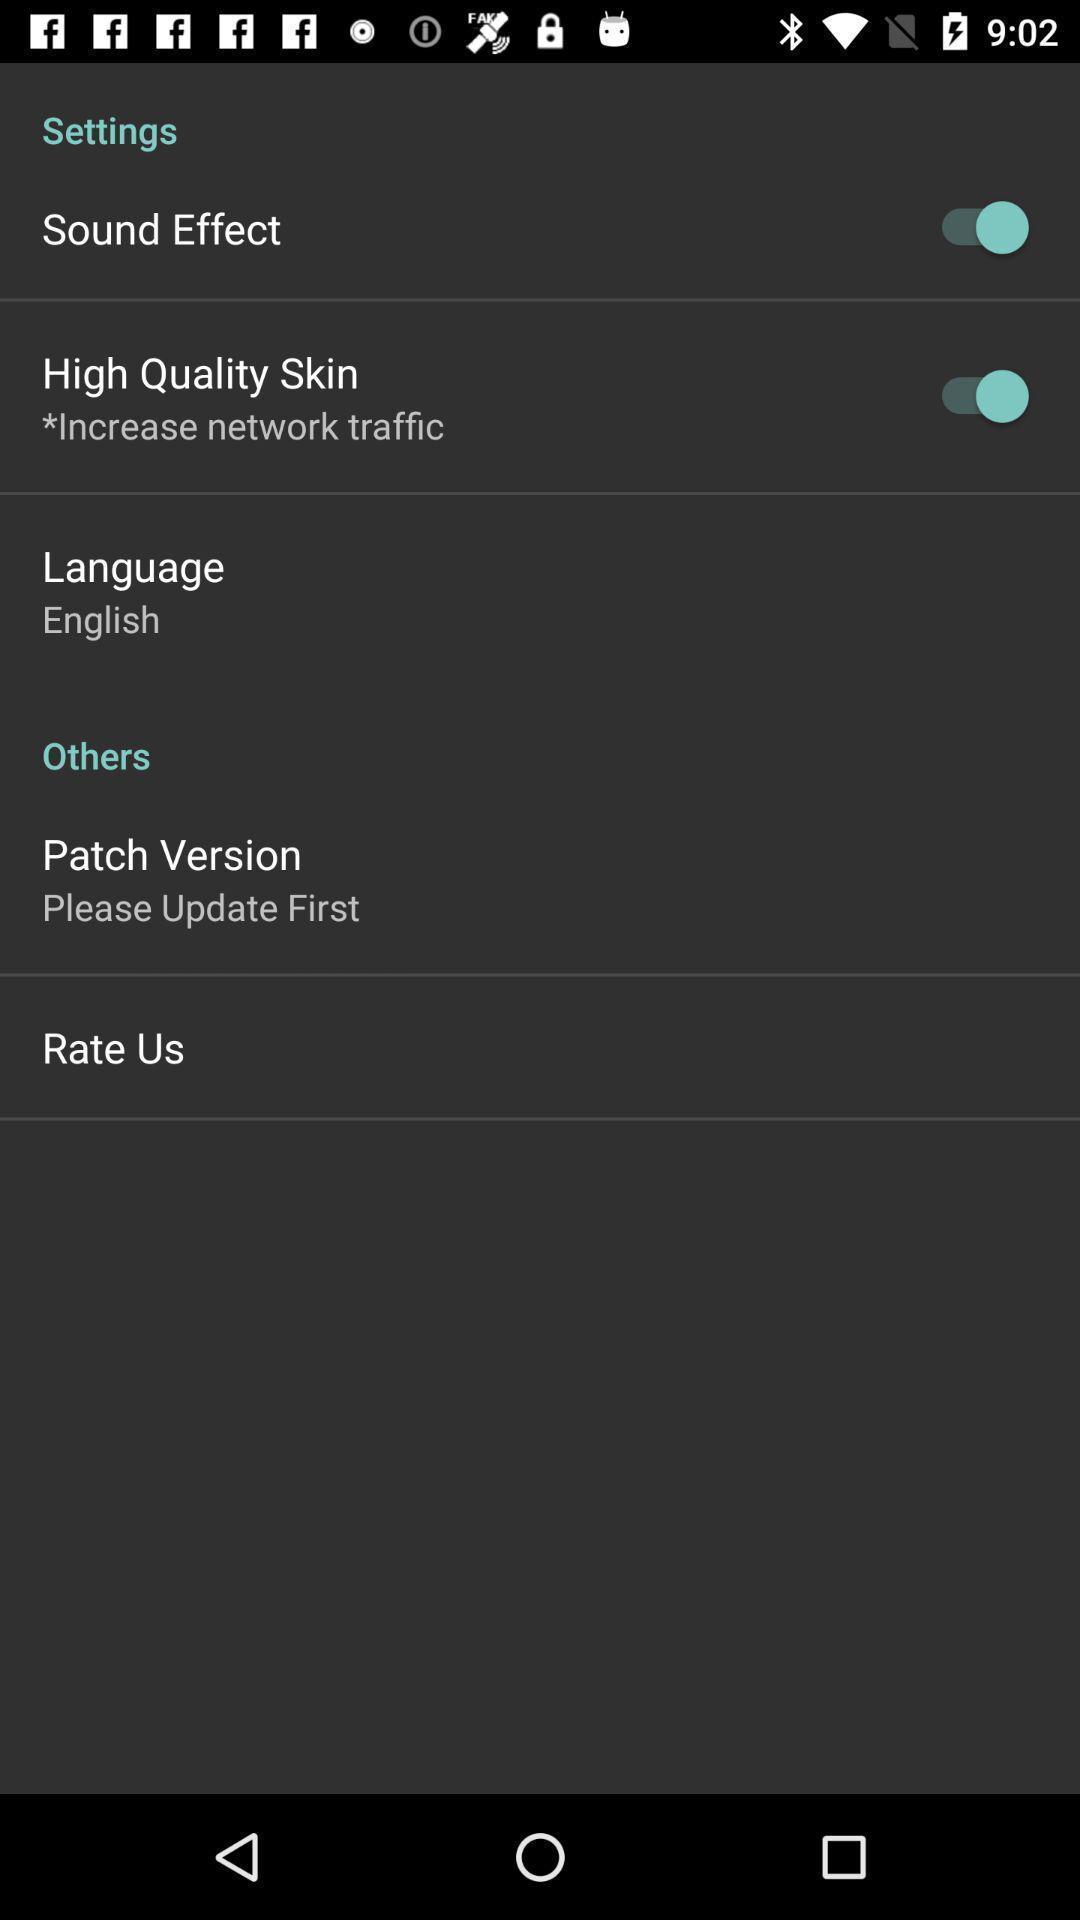Describe the key features of this screenshot. Settings page. 